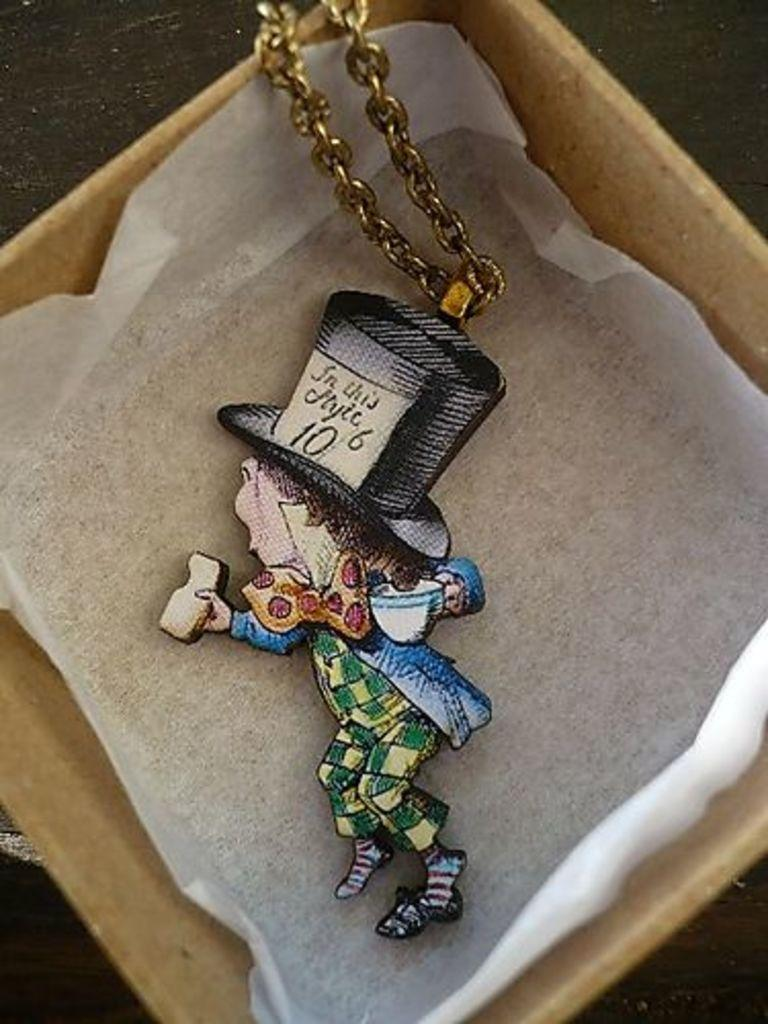What can be seen in the image? There is a box in the image. What is inside the box? There is an object inside the box. Can you describe the object inside the box? The object has a chain attached to it. What type of calculator is visible inside the box? There is no calculator present in the image. What color is the silver object inside the box? There is no silver object present in the image. 